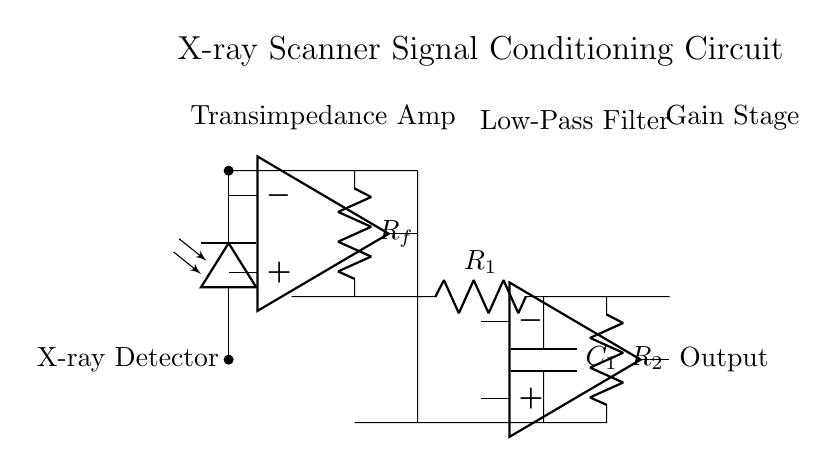What type of circuit is this? This circuit is a signal conditioning circuit specifically designed for an X-ray scanner. It includes components that process the signal received from an X-ray detector.
Answer: signal conditioning circuit What is the first component in this circuit? The first component is a photodiode, which converts X-ray signals into electrical signals. It is located at the start of the circuit diagram.
Answer: photodiode What is the purpose of the transimpedance amplifier? The transimpedance amplifier converts current from the photodiode into a voltage signal, amplifying it for further processing. This is essential for reading weak signals from the X-ray detector.
Answer: convert current to voltage What components form the low-pass filter? The low-pass filter is formed by a resistor and a capacitor, specifically R1 and C1, which filter out high-frequency noise from the amplified signal.
Answer: R1 and C1 What is the gain provided by the second stage amplifier? The second stage amplifier, which includes R2 in its design, provides additional gain to strengthen the filtered signal output from the low-pass filter before it is sent out.
Answer: R2 How many operational amplifiers are used in this circuit? There are two operational amplifiers in this circuit, one in the transimpedance section and one in the gain stage section. This enhances the overall signal conditioning process.
Answer: two What is the function of the feedback resistor Rf? The feedback resistor Rf is crucial for setting the gain of the transimpedance amplifier, as it determines how much of the output voltage is fed back to the input, effectively controlling the amplifier's gain.
Answer: set gain of transimpedance amplifier 